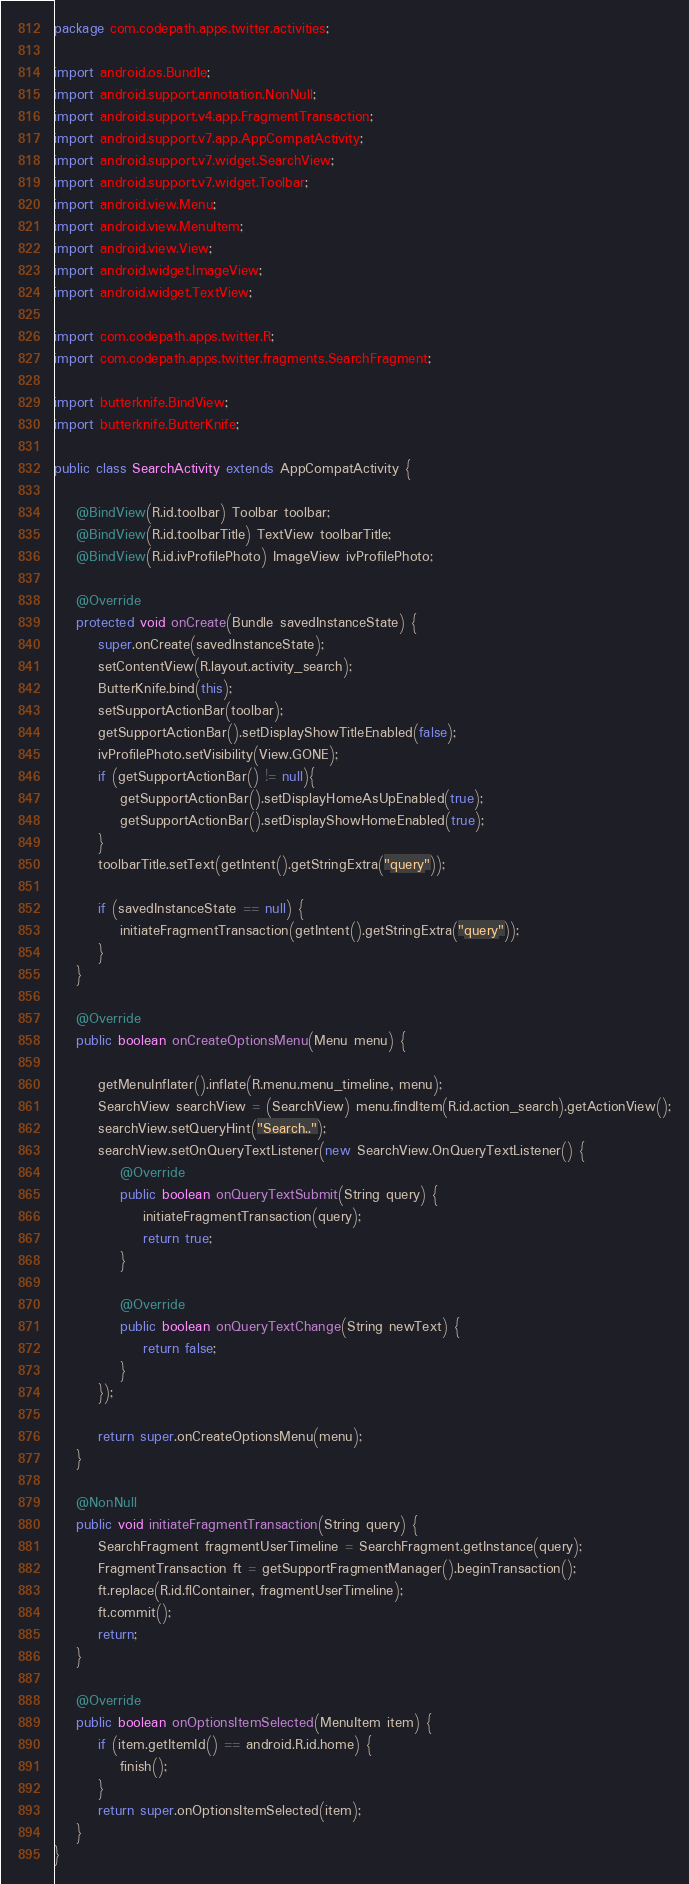<code> <loc_0><loc_0><loc_500><loc_500><_Java_>package com.codepath.apps.twitter.activities;

import android.os.Bundle;
import android.support.annotation.NonNull;
import android.support.v4.app.FragmentTransaction;
import android.support.v7.app.AppCompatActivity;
import android.support.v7.widget.SearchView;
import android.support.v7.widget.Toolbar;
import android.view.Menu;
import android.view.MenuItem;
import android.view.View;
import android.widget.ImageView;
import android.widget.TextView;

import com.codepath.apps.twitter.R;
import com.codepath.apps.twitter.fragments.SearchFragment;

import butterknife.BindView;
import butterknife.ButterKnife;

public class SearchActivity extends AppCompatActivity {

    @BindView(R.id.toolbar) Toolbar toolbar;
    @BindView(R.id.toolbarTitle) TextView toolbarTitle;
    @BindView(R.id.ivProfilePhoto) ImageView ivProfilePhoto;

    @Override
    protected void onCreate(Bundle savedInstanceState) {
        super.onCreate(savedInstanceState);
        setContentView(R.layout.activity_search);
        ButterKnife.bind(this);
        setSupportActionBar(toolbar);
        getSupportActionBar().setDisplayShowTitleEnabled(false);
        ivProfilePhoto.setVisibility(View.GONE);
        if (getSupportActionBar() != null){
            getSupportActionBar().setDisplayHomeAsUpEnabled(true);
            getSupportActionBar().setDisplayShowHomeEnabled(true);
        }
        toolbarTitle.setText(getIntent().getStringExtra("query"));

        if (savedInstanceState == null) {
            initiateFragmentTransaction(getIntent().getStringExtra("query"));
        }
    }

    @Override
    public boolean onCreateOptionsMenu(Menu menu) {

        getMenuInflater().inflate(R.menu.menu_timeline, menu);
        SearchView searchView = (SearchView) menu.findItem(R.id.action_search).getActionView();
        searchView.setQueryHint("Search..");
        searchView.setOnQueryTextListener(new SearchView.OnQueryTextListener() {
            @Override
            public boolean onQueryTextSubmit(String query) {
                initiateFragmentTransaction(query);
                return true;
            }

            @Override
            public boolean onQueryTextChange(String newText) {
                return false;
            }
        });

        return super.onCreateOptionsMenu(menu);
    }

    @NonNull
    public void initiateFragmentTransaction(String query) {
        SearchFragment fragmentUserTimeline = SearchFragment.getInstance(query);
        FragmentTransaction ft = getSupportFragmentManager().beginTransaction();
        ft.replace(R.id.flContainer, fragmentUserTimeline);
        ft.commit();
        return;
    }

    @Override
    public boolean onOptionsItemSelected(MenuItem item) {
        if (item.getItemId() == android.R.id.home) {
            finish();
        }
        return super.onOptionsItemSelected(item);
    }
}
</code> 